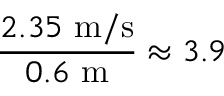<formula> <loc_0><loc_0><loc_500><loc_500>\frac { 2 . 3 5 m / s } { 0 . 6 m } \approx 3 . 9</formula> 